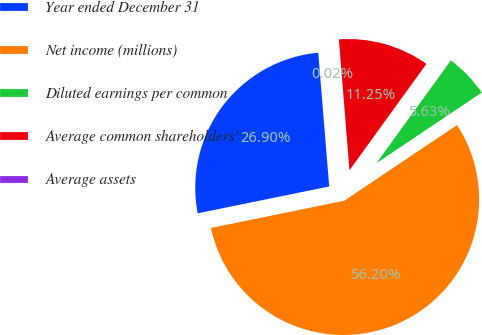Convert chart to OTSL. <chart><loc_0><loc_0><loc_500><loc_500><pie_chart><fcel>Year ended December 31<fcel>Net income (millions)<fcel>Diluted earnings per common<fcel>Average common shareholders'<fcel>Average assets<nl><fcel>26.9%<fcel>56.19%<fcel>5.63%<fcel>11.25%<fcel>0.02%<nl></chart> 